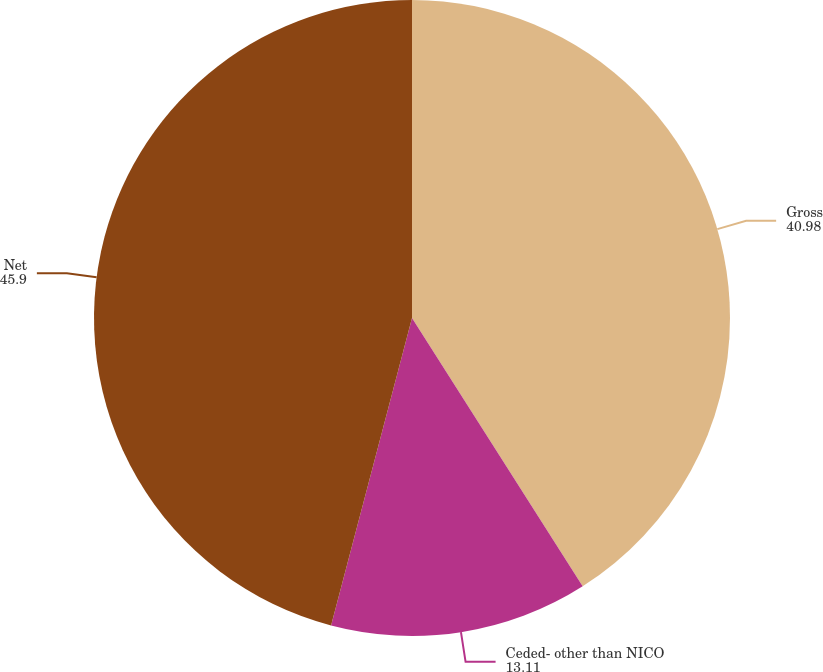<chart> <loc_0><loc_0><loc_500><loc_500><pie_chart><fcel>Gross<fcel>Ceded- other than NICO<fcel>Net<nl><fcel>40.98%<fcel>13.11%<fcel>45.9%<nl></chart> 